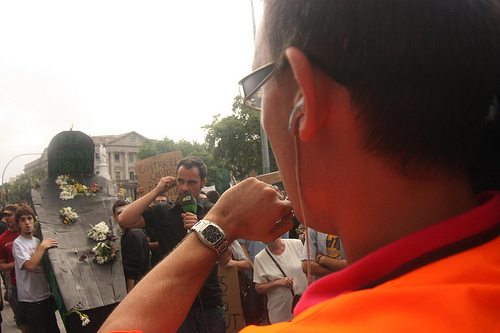<image>
Can you confirm if the watch is on the man? No. The watch is not positioned on the man. They may be near each other, but the watch is not supported by or resting on top of the man. Is the man behind the woman? No. The man is not behind the woman. From this viewpoint, the man appears to be positioned elsewhere in the scene. 